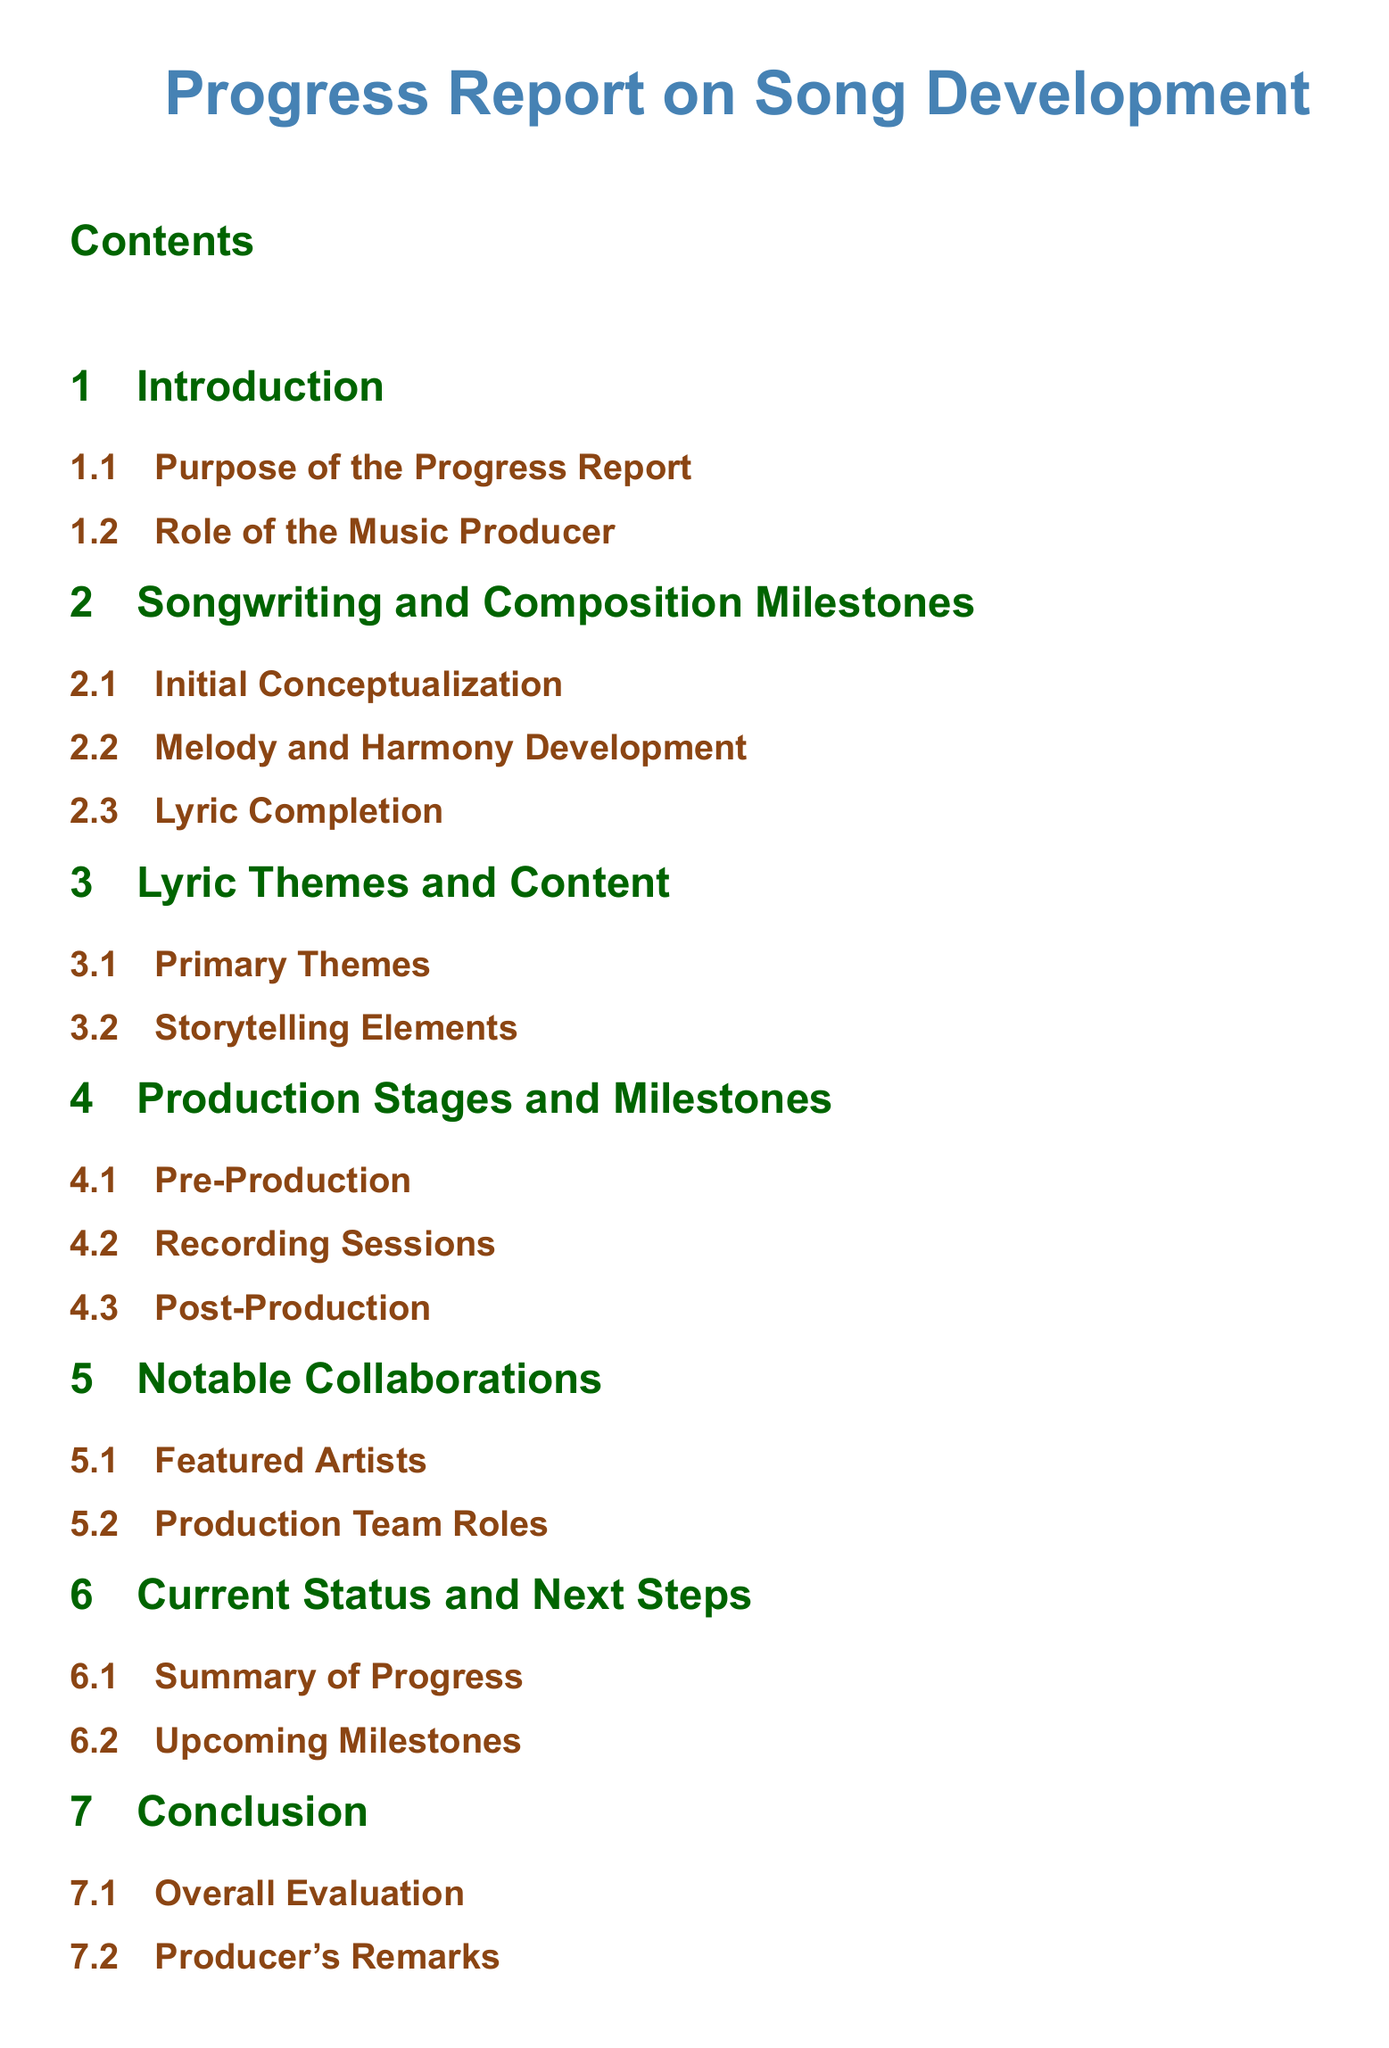What is the title of the document? The title of the document is the first item presented, indicating the overall focus of the content.
Answer: Progress Report on Song Development What section follows the Introduction? This question seeks to identify the next major section in the document structure immediately following the Introduction section.
Answer: Songwriting and Composition Milestones How many primary themes are discussed in the Lyric Themes and Content section? The document outlines specific elements within the Lyric Themes and Content section, seeking details about the number of themes mentioned.
Answer: Primary Themes What is the main focus of the Notable Collaborations section? This section outlines critical contributions and collaborations in the music production process, therefore the answer should reflect that emphasis.
Answer: Featured Artists What stage comes after Pre-Production in the Production Stages and Milestones section? The order of production stages is indicated in the document, and this question asks for the specific stage that follows Pre-Production.
Answer: Recording Sessions What does the Conclusion section evaluate? In the document, the conclusion aims to provide an overarching assessment and reflections on the project, thus the answer aligns with that scope.
Answer: Overall Evaluation What are the two subsections in the Current Status and Next Steps section? This question asks for specific components covered under the Current Status and Next Steps section, ensuring respondents name both.
Answer: Summary of Progress, Upcoming Milestones Who is responsible for the overall production roles mentioned? This question inquires who holds the identified responsibilities within the production team, focusing on the team roles especially highlighted in the document.
Answer: Production Team Roles 